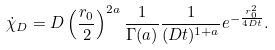Convert formula to latex. <formula><loc_0><loc_0><loc_500><loc_500>\dot { \chi } _ { D } = D \left ( \frac { r _ { 0 } } { 2 } \right ) ^ { 2 a } \frac { 1 } { \Gamma ( a ) } \frac { 1 } { ( D t ) ^ { 1 + a } } e ^ { - \frac { r _ { 0 } ^ { 2 } } { 4 D t } } .</formula> 